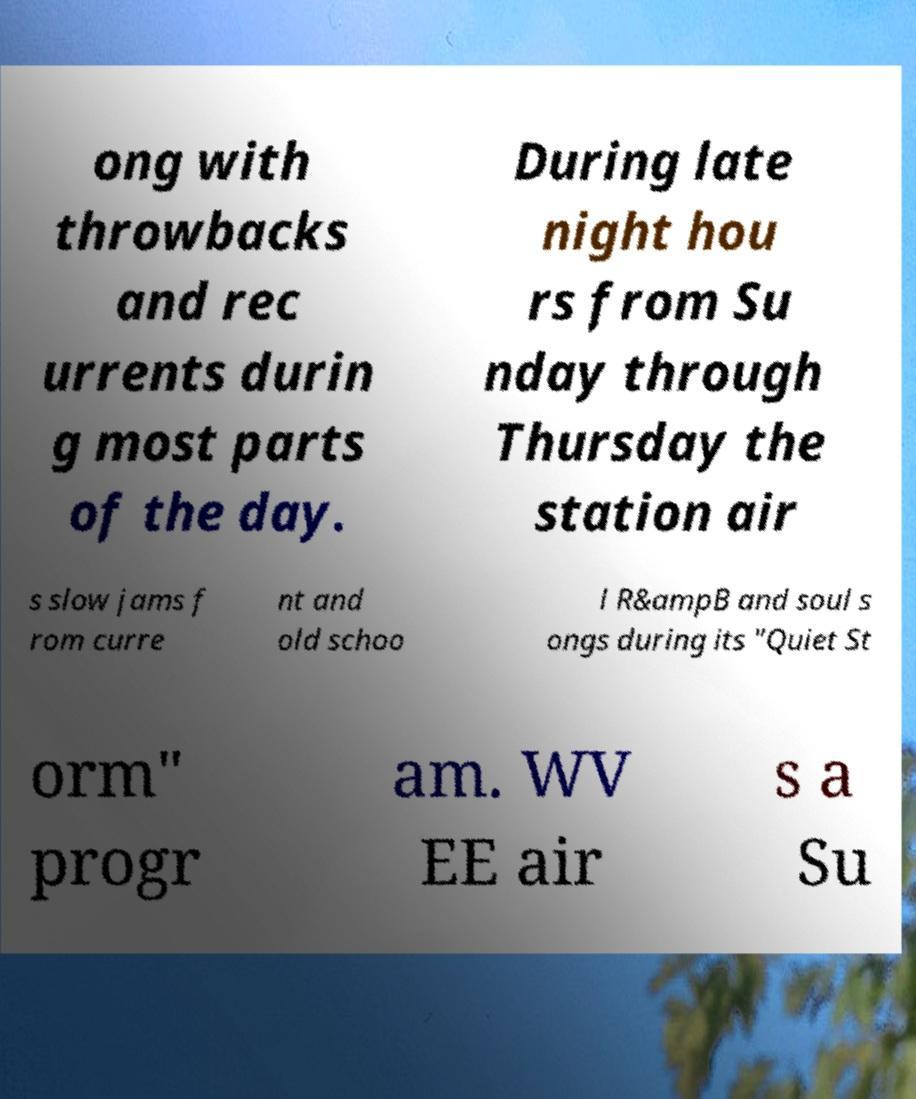Could you assist in decoding the text presented in this image and type it out clearly? ong with throwbacks and rec urrents durin g most parts of the day. During late night hou rs from Su nday through Thursday the station air s slow jams f rom curre nt and old schoo l R&ampB and soul s ongs during its "Quiet St orm" progr am. WV EE air s a Su 